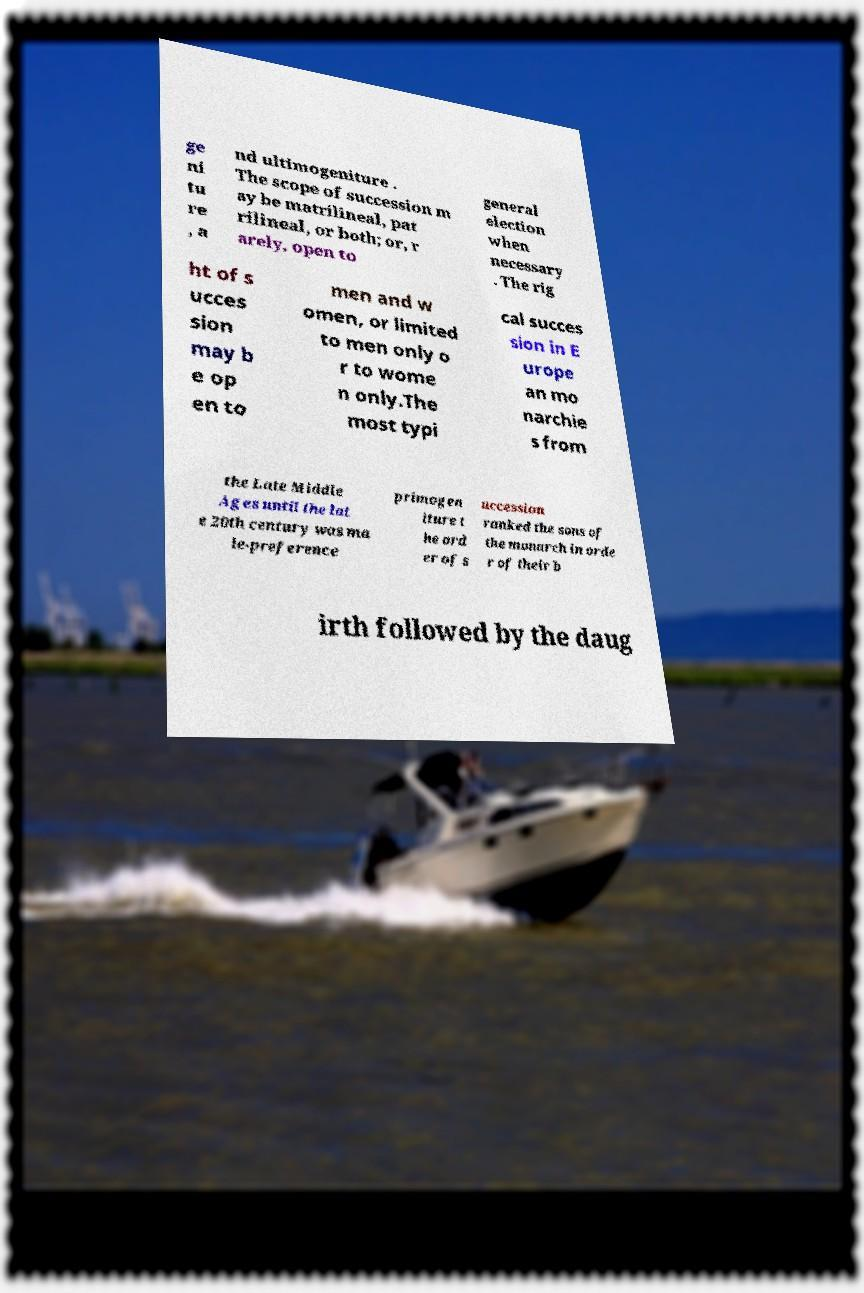Please read and relay the text visible in this image. What does it say? ge ni tu re , a nd ultimogeniture . The scope of succession m ay be matrilineal, pat rilineal, or both; or, r arely, open to general election when necessary . The rig ht of s ucces sion may b e op en to men and w omen, or limited to men only o r to wome n only.The most typi cal succes sion in E urope an mo narchie s from the Late Middle Ages until the lat e 20th century was ma le-preference primogen iture t he ord er of s uccession ranked the sons of the monarch in orde r of their b irth followed by the daug 